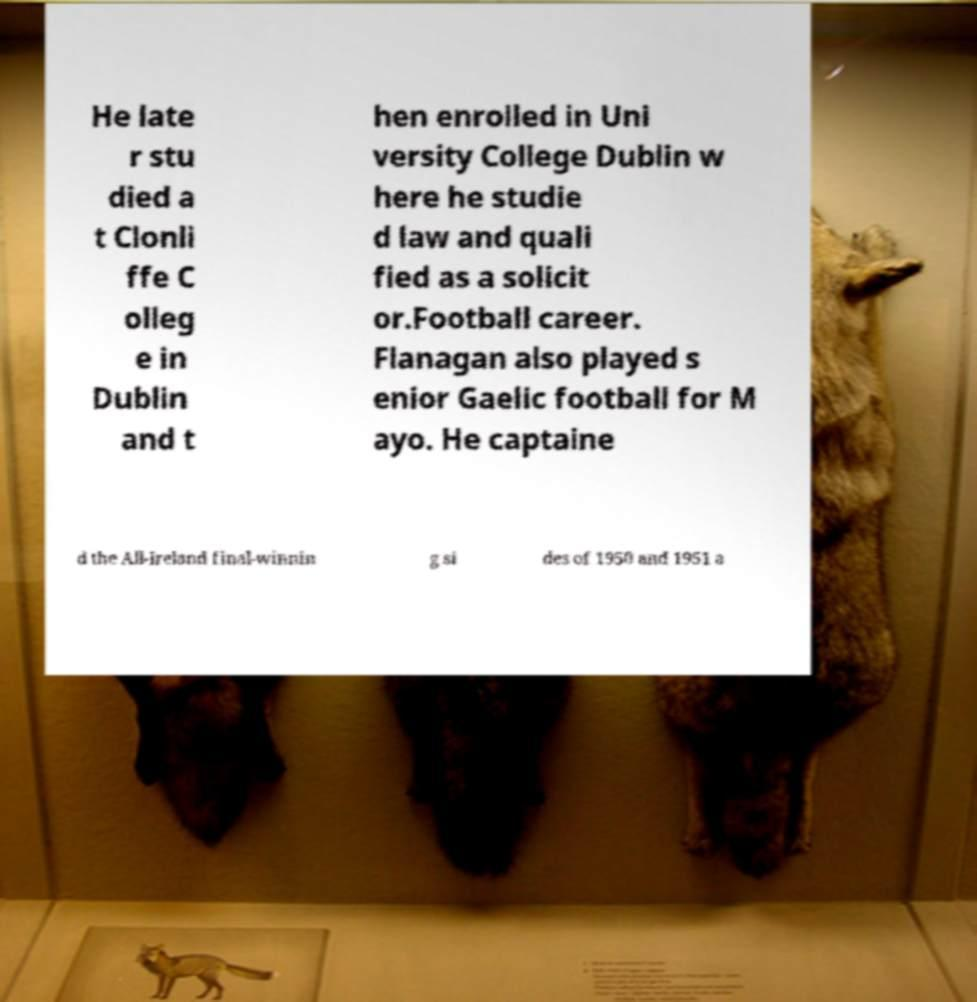For documentation purposes, I need the text within this image transcribed. Could you provide that? He late r stu died a t Clonli ffe C olleg e in Dublin and t hen enrolled in Uni versity College Dublin w here he studie d law and quali fied as a solicit or.Football career. Flanagan also played s enior Gaelic football for M ayo. He captaine d the All-Ireland final-winnin g si des of 1950 and 1951 a 